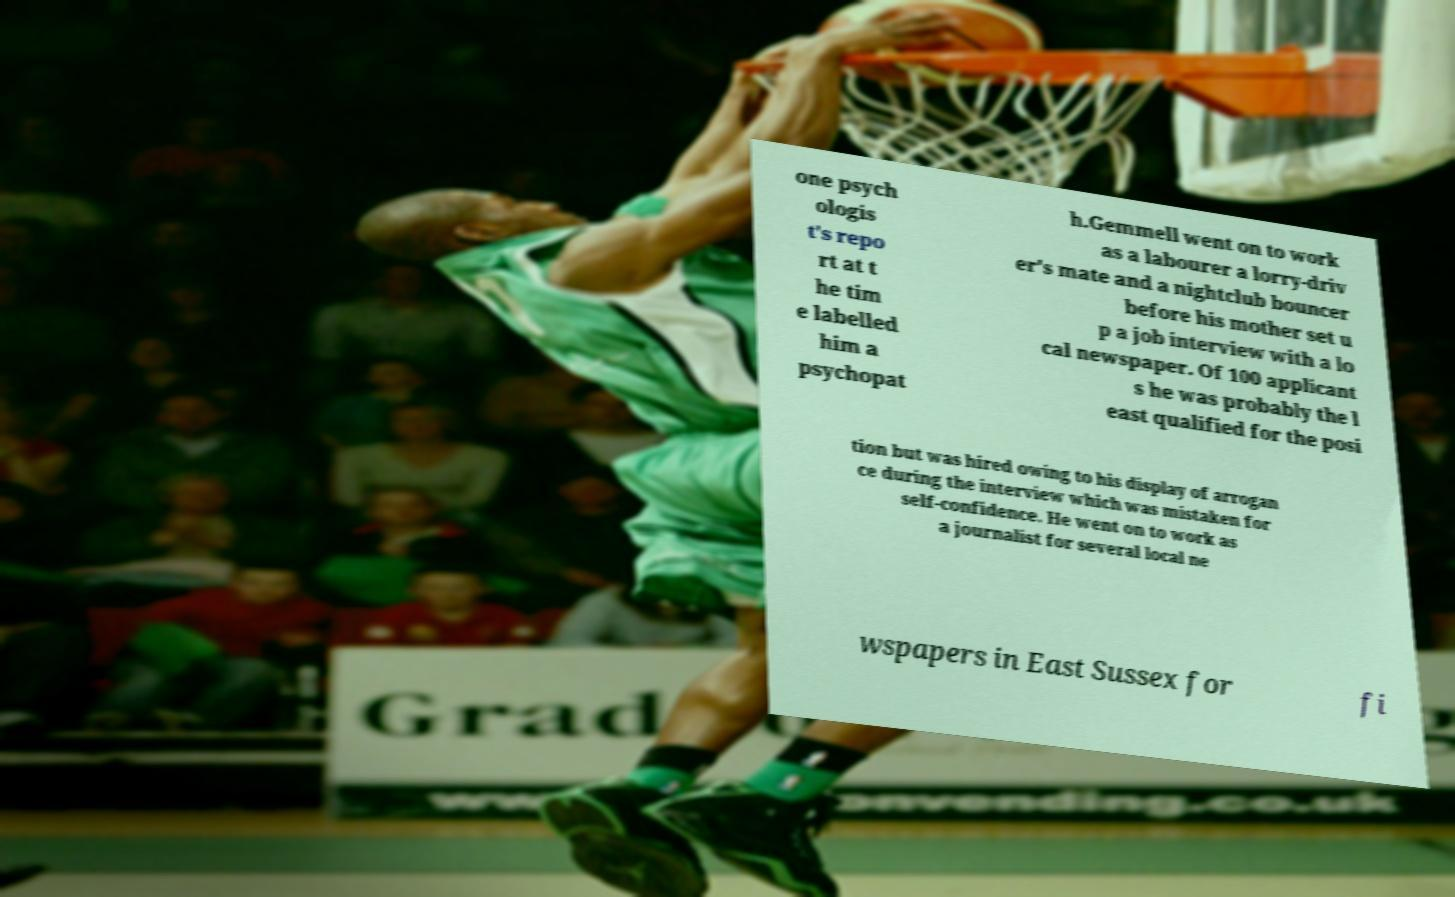I need the written content from this picture converted into text. Can you do that? one psych ologis t's repo rt at t he tim e labelled him a psychopat h.Gemmell went on to work as a labourer a lorry-driv er's mate and a nightclub bouncer before his mother set u p a job interview with a lo cal newspaper. Of 100 applicant s he was probably the l east qualified for the posi tion but was hired owing to his display of arrogan ce during the interview which was mistaken for self-confidence. He went on to work as a journalist for several local ne wspapers in East Sussex for fi 